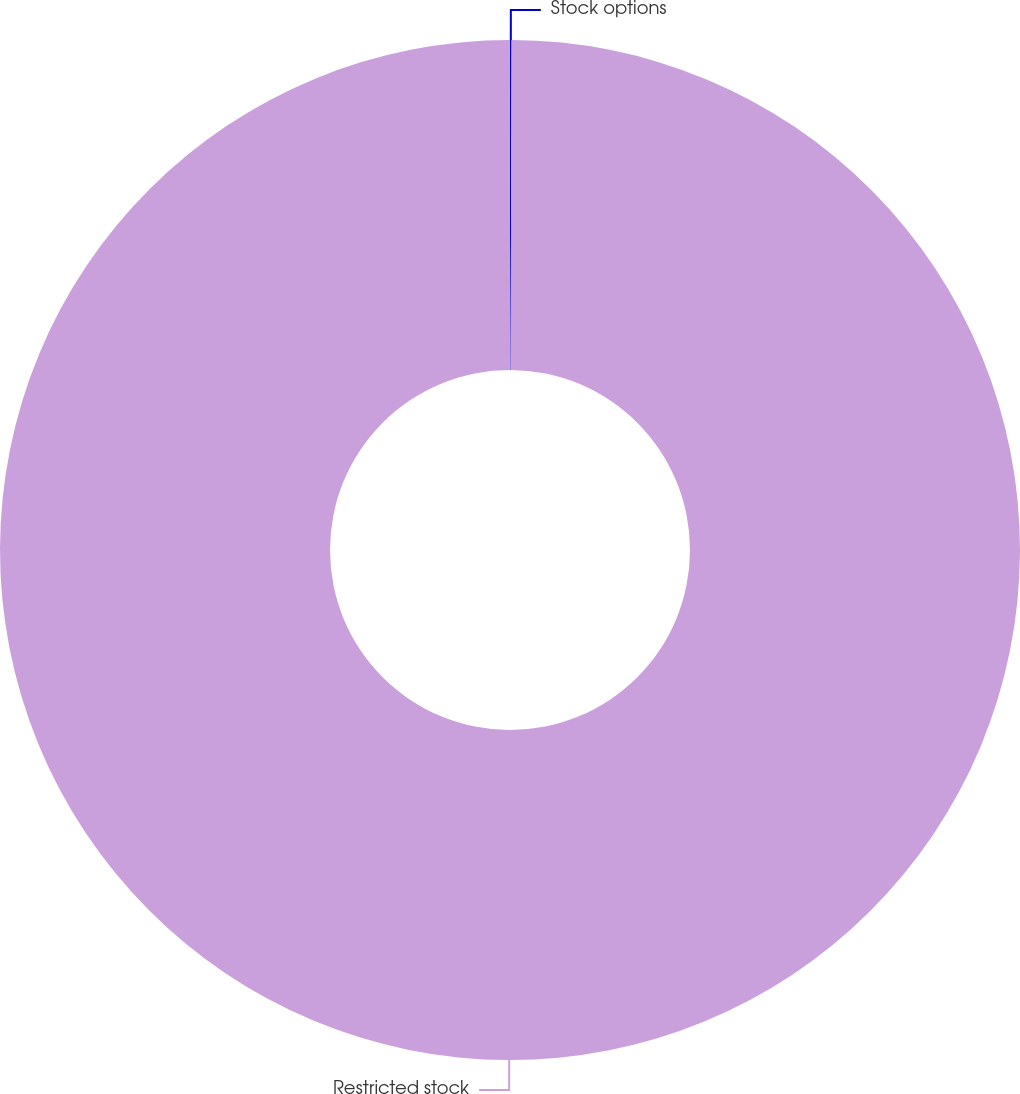<chart> <loc_0><loc_0><loc_500><loc_500><pie_chart><fcel>Stock options<fcel>Restricted stock<nl><fcel>0.05%<fcel>99.95%<nl></chart> 